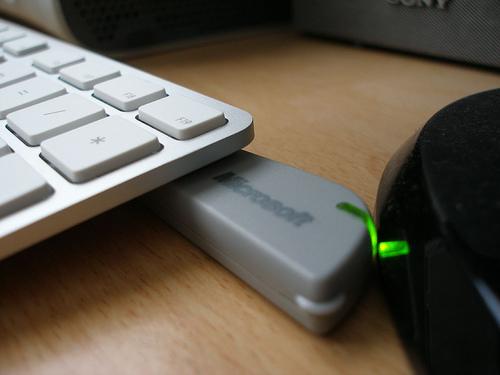What brand is the USB?
Write a very short answer. Microsoft. Is there anything in this picture than can transfer data to another computer?
Keep it brief. Yes. Can you form the word "weds" from the letters that can be read on this keyboard?
Keep it brief. No. Is the key forward slash visible?
Keep it brief. Yes. 